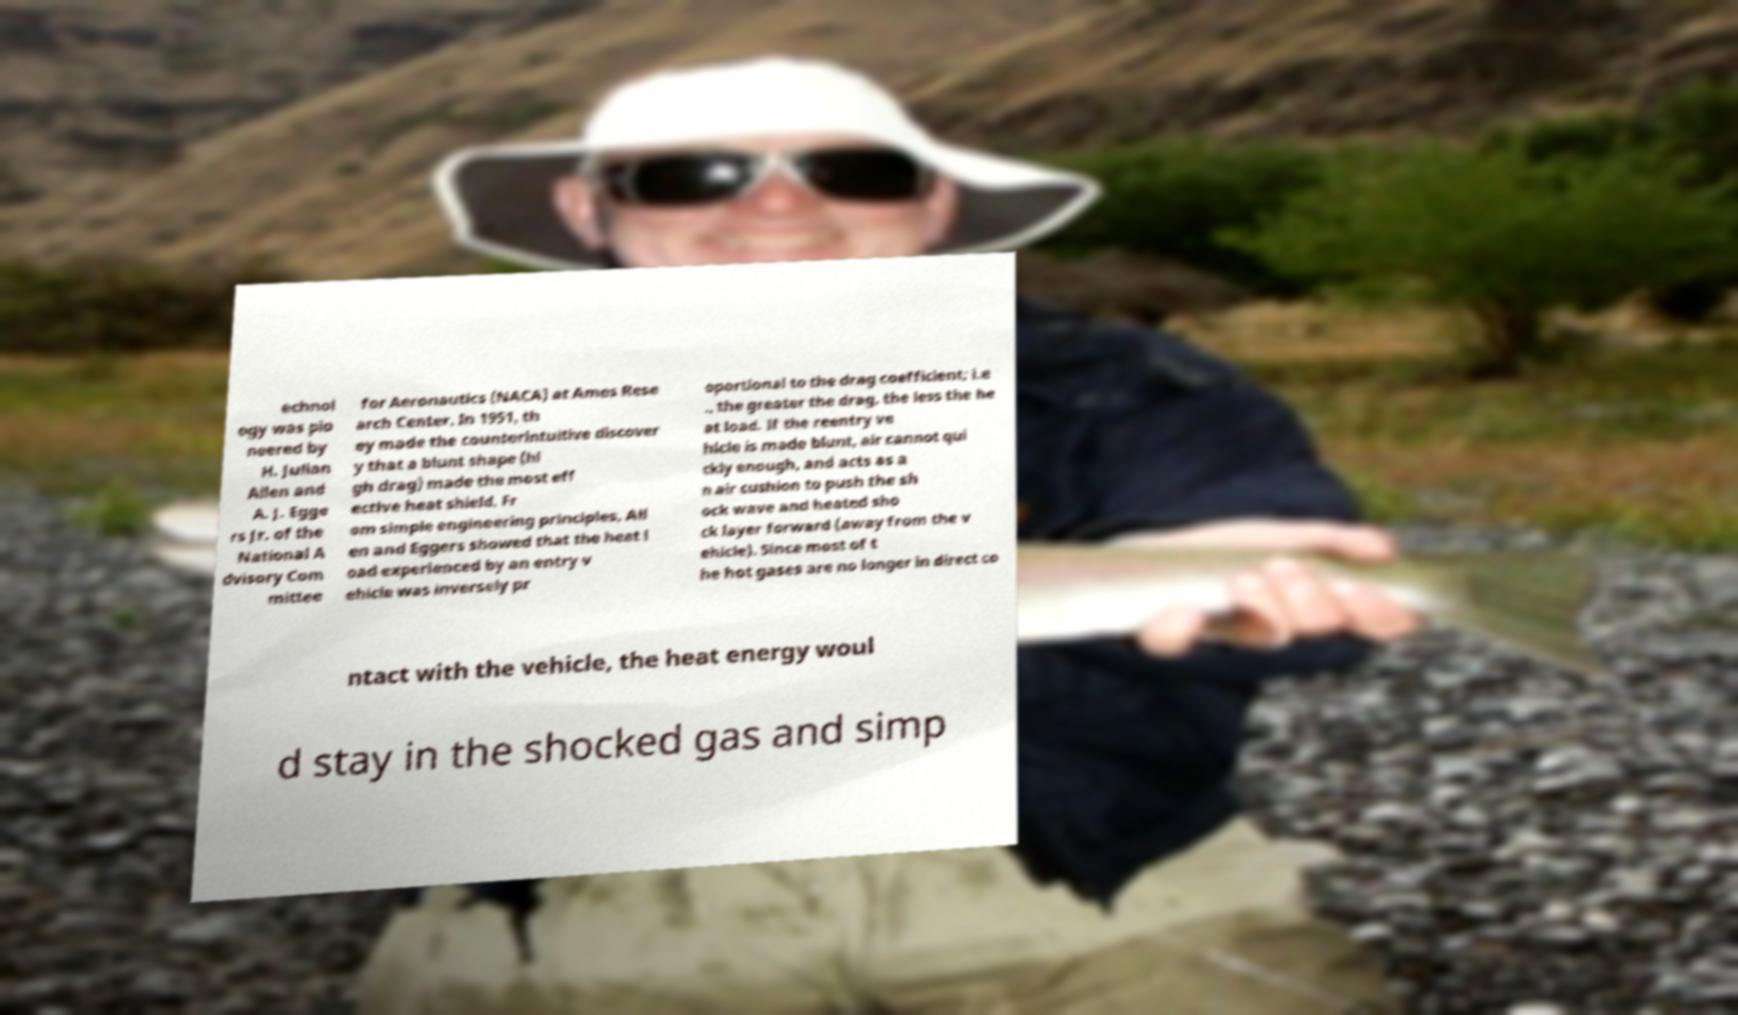There's text embedded in this image that I need extracted. Can you transcribe it verbatim? echnol ogy was pio neered by H. Julian Allen and A. J. Egge rs Jr. of the National A dvisory Com mittee for Aeronautics (NACA) at Ames Rese arch Center. In 1951, th ey made the counterintuitive discover y that a blunt shape (hi gh drag) made the most eff ective heat shield. Fr om simple engineering principles, All en and Eggers showed that the heat l oad experienced by an entry v ehicle was inversely pr oportional to the drag coefficient; i.e ., the greater the drag, the less the he at load. If the reentry ve hicle is made blunt, air cannot qui ckly enough, and acts as a n air cushion to push the sh ock wave and heated sho ck layer forward (away from the v ehicle). Since most of t he hot gases are no longer in direct co ntact with the vehicle, the heat energy woul d stay in the shocked gas and simp 